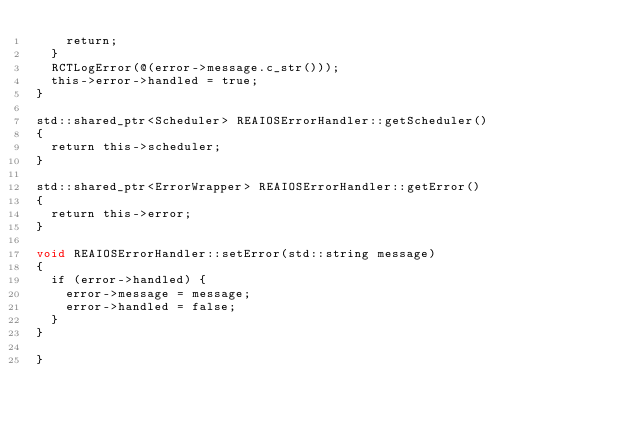<code> <loc_0><loc_0><loc_500><loc_500><_ObjectiveC_>    return;
  }
  RCTLogError(@(error->message.c_str()));
  this->error->handled = true;
}

std::shared_ptr<Scheduler> REAIOSErrorHandler::getScheduler()
{
  return this->scheduler;
}

std::shared_ptr<ErrorWrapper> REAIOSErrorHandler::getError()
{
  return this->error;
}

void REAIOSErrorHandler::setError(std::string message)
{
  if (error->handled) {
    error->message = message;
    error->handled = false;
  }
}

}
</code> 